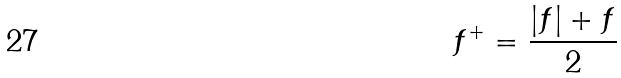Convert formula to latex. <formula><loc_0><loc_0><loc_500><loc_500>f ^ { + } = \frac { | f | + f } { 2 }</formula> 